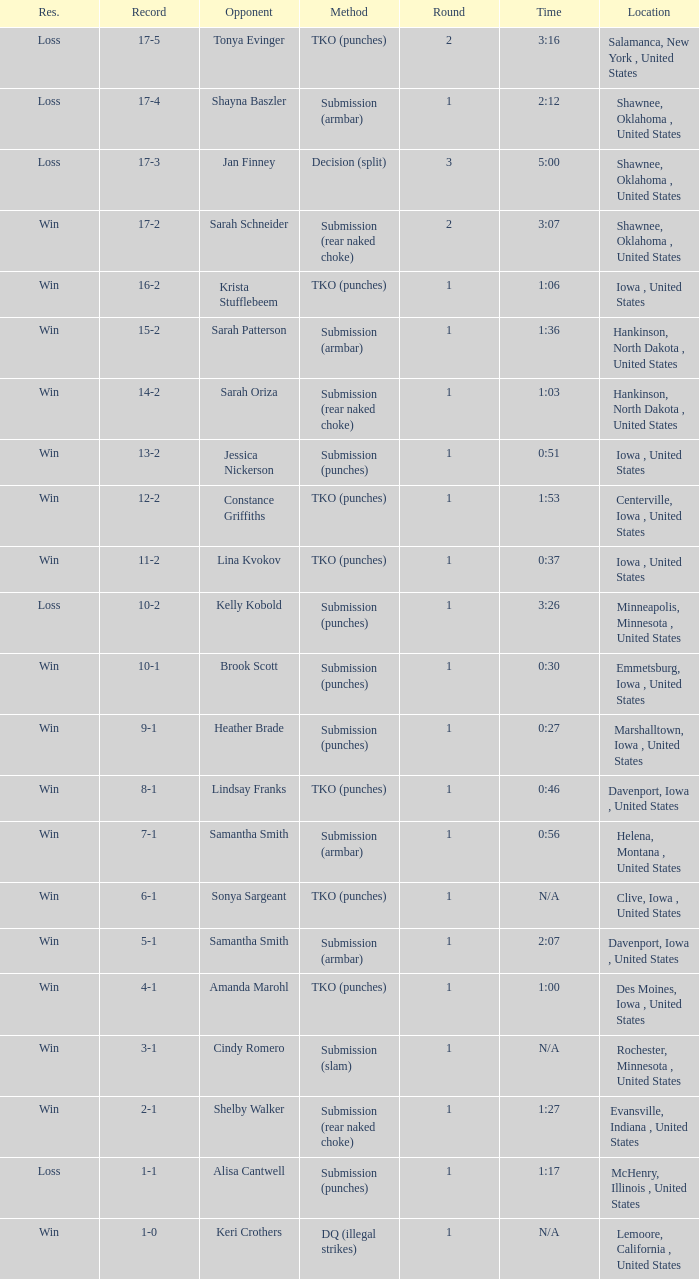What is the highest number of rounds for a 3:16 fight? 2.0. Could you parse the entire table? {'header': ['Res.', 'Record', 'Opponent', 'Method', 'Round', 'Time', 'Location'], 'rows': [['Loss', '17-5', 'Tonya Evinger', 'TKO (punches)', '2', '3:16', 'Salamanca, New York , United States'], ['Loss', '17-4', 'Shayna Baszler', 'Submission (armbar)', '1', '2:12', 'Shawnee, Oklahoma , United States'], ['Loss', '17-3', 'Jan Finney', 'Decision (split)', '3', '5:00', 'Shawnee, Oklahoma , United States'], ['Win', '17-2', 'Sarah Schneider', 'Submission (rear naked choke)', '2', '3:07', 'Shawnee, Oklahoma , United States'], ['Win', '16-2', 'Krista Stufflebeem', 'TKO (punches)', '1', '1:06', 'Iowa , United States'], ['Win', '15-2', 'Sarah Patterson', 'Submission (armbar)', '1', '1:36', 'Hankinson, North Dakota , United States'], ['Win', '14-2', 'Sarah Oriza', 'Submission (rear naked choke)', '1', '1:03', 'Hankinson, North Dakota , United States'], ['Win', '13-2', 'Jessica Nickerson', 'Submission (punches)', '1', '0:51', 'Iowa , United States'], ['Win', '12-2', 'Constance Griffiths', 'TKO (punches)', '1', '1:53', 'Centerville, Iowa , United States'], ['Win', '11-2', 'Lina Kvokov', 'TKO (punches)', '1', '0:37', 'Iowa , United States'], ['Loss', '10-2', 'Kelly Kobold', 'Submission (punches)', '1', '3:26', 'Minneapolis, Minnesota , United States'], ['Win', '10-1', 'Brook Scott', 'Submission (punches)', '1', '0:30', 'Emmetsburg, Iowa , United States'], ['Win', '9-1', 'Heather Brade', 'Submission (punches)', '1', '0:27', 'Marshalltown, Iowa , United States'], ['Win', '8-1', 'Lindsay Franks', 'TKO (punches)', '1', '0:46', 'Davenport, Iowa , United States'], ['Win', '7-1', 'Samantha Smith', 'Submission (armbar)', '1', '0:56', 'Helena, Montana , United States'], ['Win', '6-1', 'Sonya Sargeant', 'TKO (punches)', '1', 'N/A', 'Clive, Iowa , United States'], ['Win', '5-1', 'Samantha Smith', 'Submission (armbar)', '1', '2:07', 'Davenport, Iowa , United States'], ['Win', '4-1', 'Amanda Marohl', 'TKO (punches)', '1', '1:00', 'Des Moines, Iowa , United States'], ['Win', '3-1', 'Cindy Romero', 'Submission (slam)', '1', 'N/A', 'Rochester, Minnesota , United States'], ['Win', '2-1', 'Shelby Walker', 'Submission (rear naked choke)', '1', '1:27', 'Evansville, Indiana , United States'], ['Loss', '1-1', 'Alisa Cantwell', 'Submission (punches)', '1', '1:17', 'McHenry, Illinois , United States'], ['Win', '1-0', 'Keri Crothers', 'DQ (illegal strikes)', '1', 'N/A', 'Lemoore, California , United States']]} 